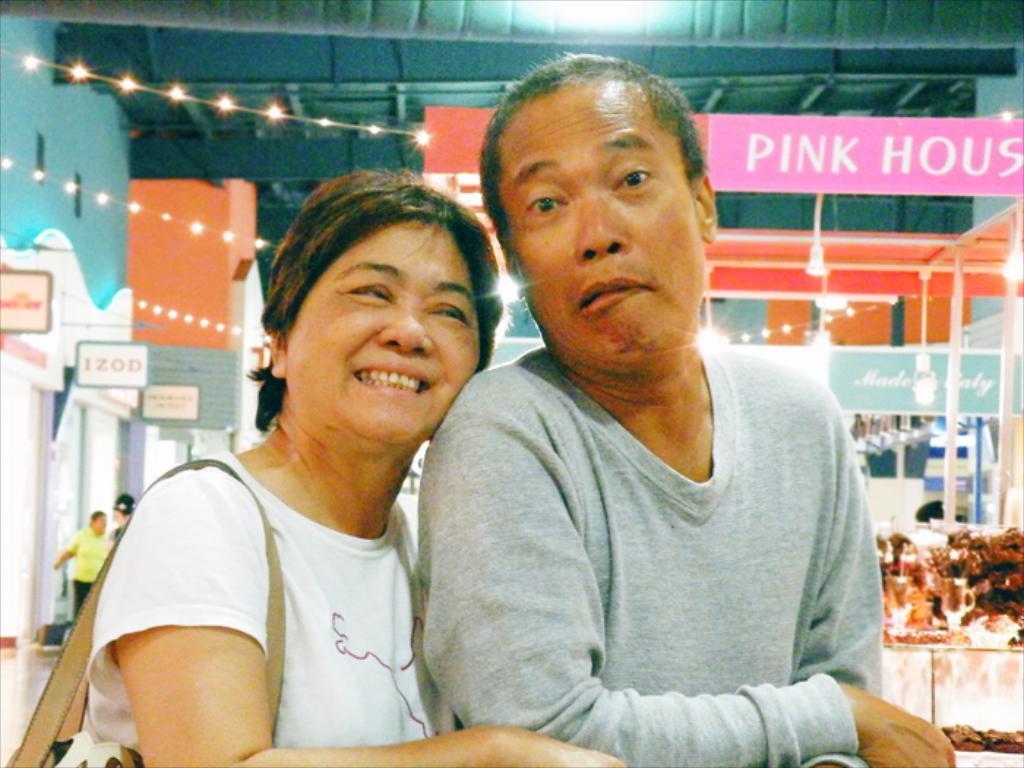Can you describe this image briefly? At the foreground of the image we can see two persons hugging each other, lady person carrying bag and at the background of the image there are some persons, boards, lights and roof. 